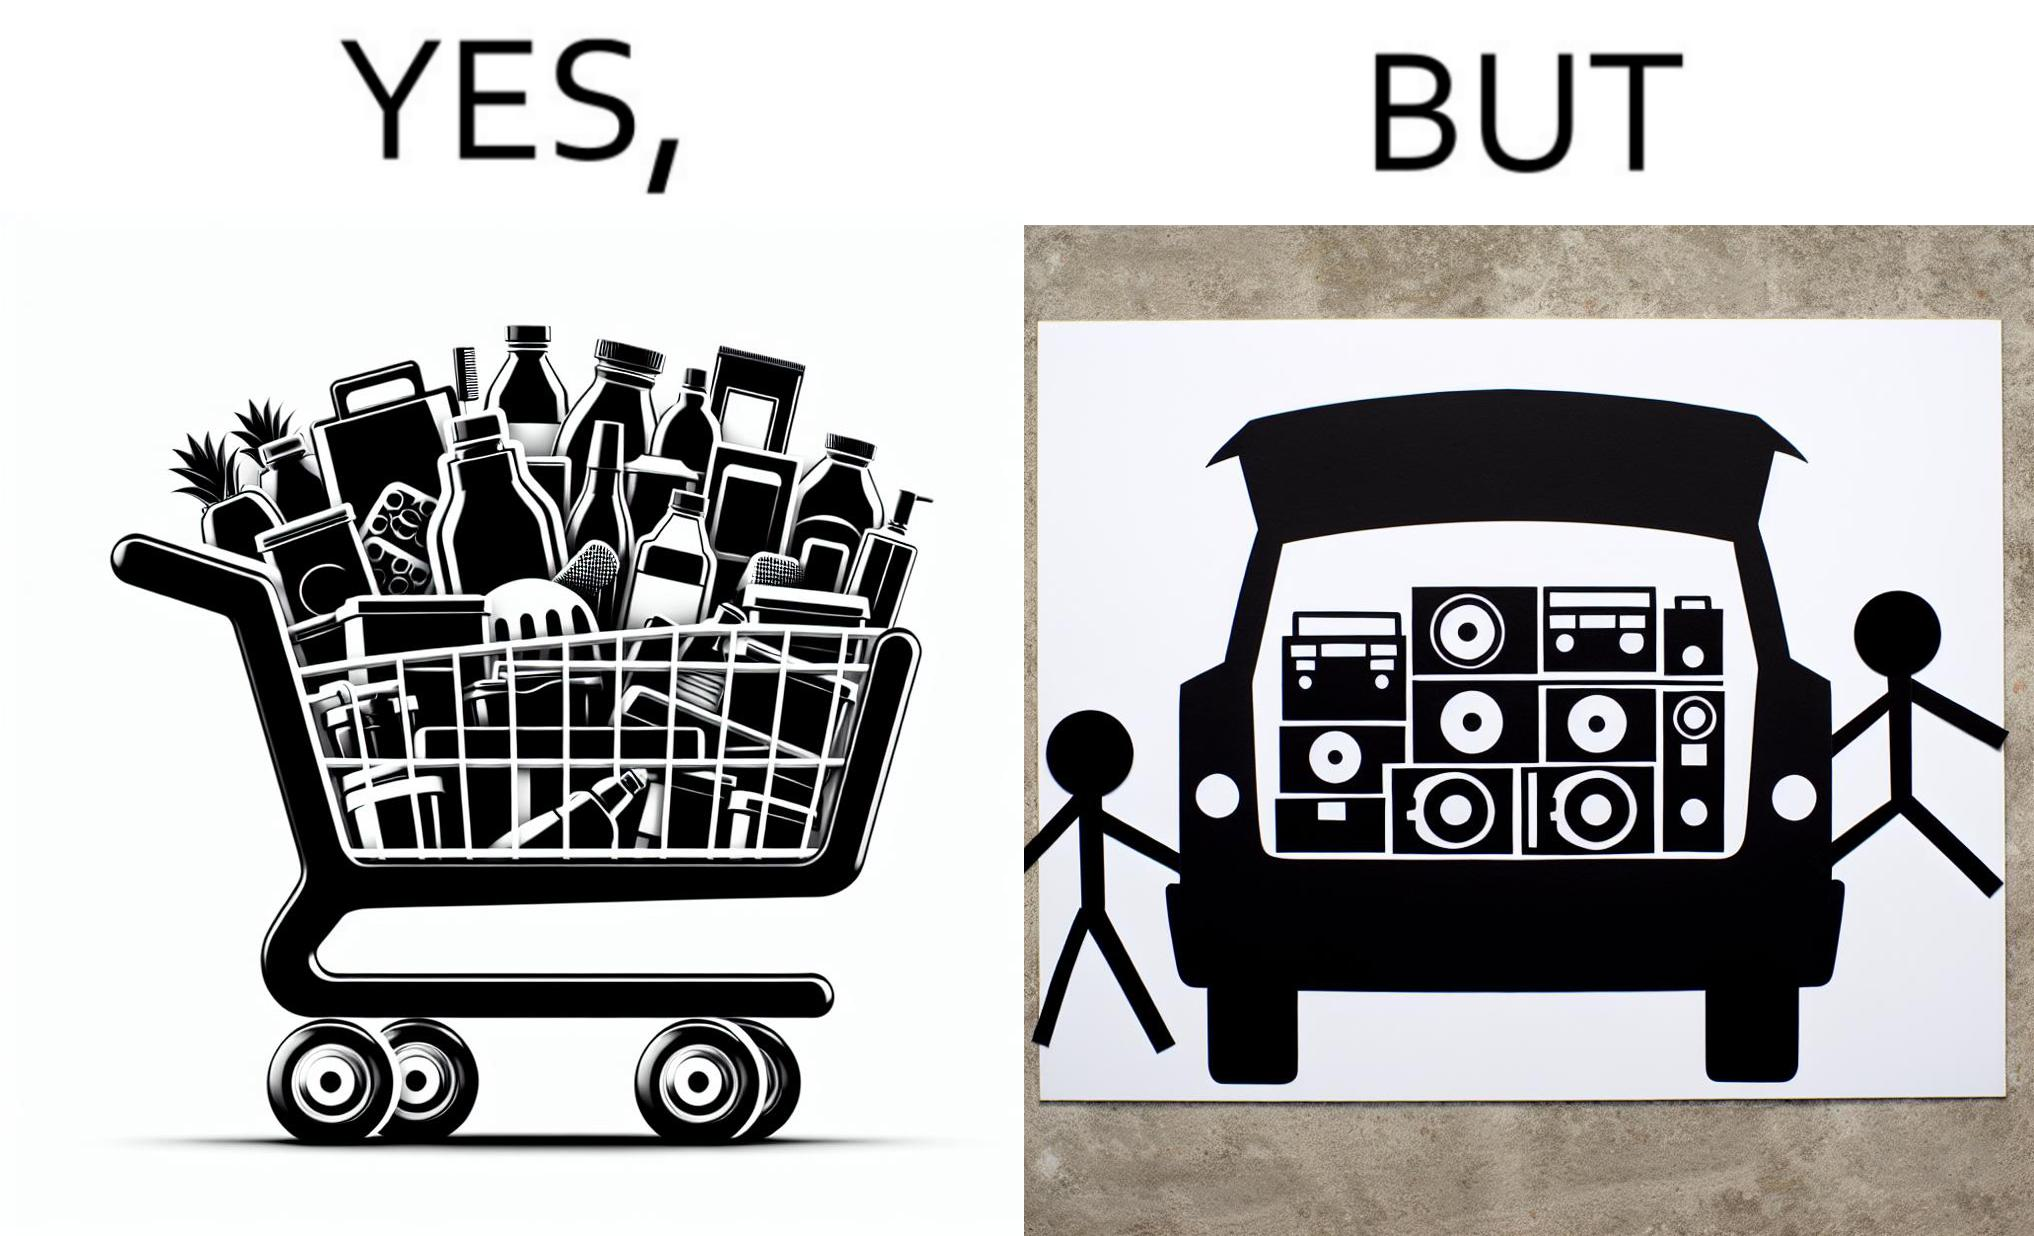What do you see in each half of this image? In the left part of the image: a shopping cart full of items In the right part of the image: a black car with its trunk lid open and some boxes, probably speakers, kept in the trunk 